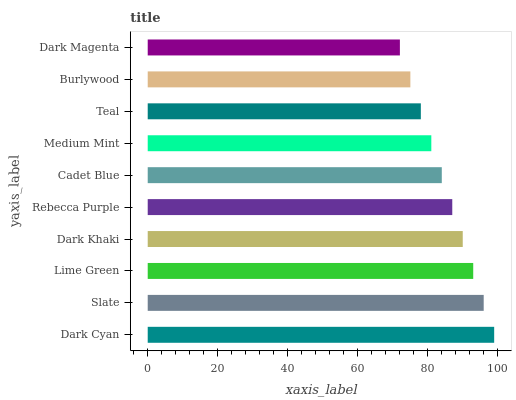Is Dark Magenta the minimum?
Answer yes or no. Yes. Is Dark Cyan the maximum?
Answer yes or no. Yes. Is Slate the minimum?
Answer yes or no. No. Is Slate the maximum?
Answer yes or no. No. Is Dark Cyan greater than Slate?
Answer yes or no. Yes. Is Slate less than Dark Cyan?
Answer yes or no. Yes. Is Slate greater than Dark Cyan?
Answer yes or no. No. Is Dark Cyan less than Slate?
Answer yes or no. No. Is Rebecca Purple the high median?
Answer yes or no. Yes. Is Cadet Blue the low median?
Answer yes or no. Yes. Is Dark Khaki the high median?
Answer yes or no. No. Is Dark Khaki the low median?
Answer yes or no. No. 